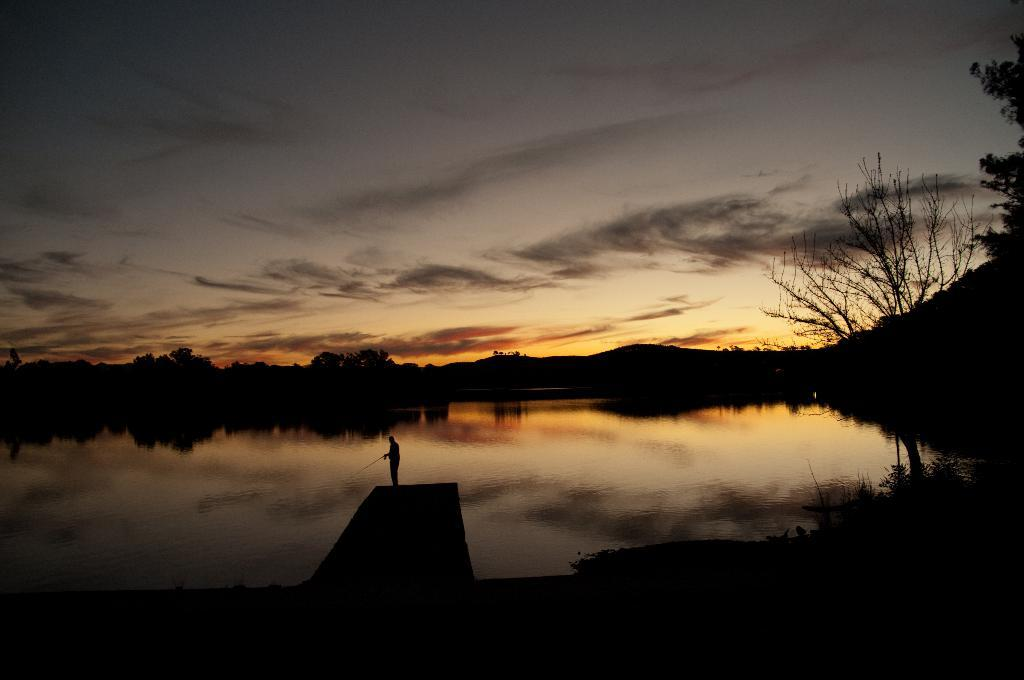Who or what is present in the image? There is a person in the image. What natural element can be seen in the image? Water is visible in the image. What type of vegetation is present in the image? Trees are in the image. What is visible in the background of the image? The sky is visible in the image, and clouds are present. How would you describe the lighting in the image? The image appears to be slightly dark. How many cacti can be seen in the image? There are no cacti present in the image. What type of fish is swimming in the water in the image? There is no fish visible in the image; it only shows water. 